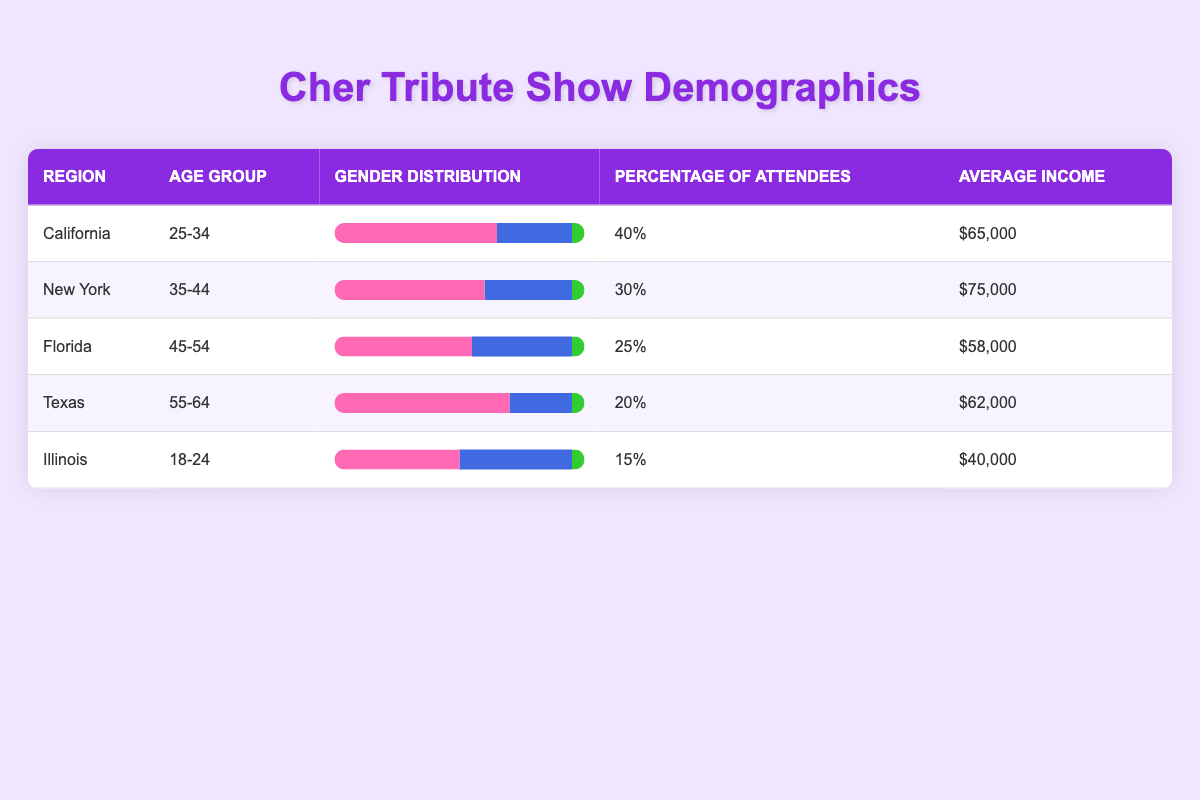What is the average income of attendees in Florida? The table shows that the average income for Florida is listed as $58,000. Therefore, this information can be directly retrieved from the table.
Answer: $58,000 Which region has the highest percentage of attendees? According to the table, California has the highest percentage of attendees at 40%, which is greater than the percentages listed for New York (30%), Florida (25%), Texas (20%), and Illinois (15%).
Answer: California Is the gender distribution for Texas primarily female? In Texas, the gender distribution indicates that 70% are female, which is a majority compared to males (25%) and others (5%). Thus, the statement is true.
Answer: Yes What is the combined percentage of attendees from California and New York? The percentage of attendees in California is 40%, and in New York, it is 30%. Adding these two percentages together (40 + 30) gives a total of 70%.
Answer: 70% Which age group has the lowest representation in terms of percentage of attendees? Upon examining the percentages of attendees, Illinois (18-24) has the lowest at 15%, compared to other regions: California (40%), New York (30%), Florida (25%), and Texas (20%).
Answer: Illinois How many total gender percentages sum to 100% for each region? Gender distribution percentages for California (65% female, 30% male, 5% other), New York (60% female, 35% male, 5% other), Florida (55% female, 40% male, 5% other), Texas (70% female, 25% male, 5% other), and Illinois (50% female, 45% male, 5% other) all add up to 100% for each region.
Answer: Yes Which region shows a male percentage higher than 30% in gender distribution? In analyzing the gender distribution, Florida has 40% male and New York has 35% male. Both are higher than 30%. Hence, the answer is based on those two regions meeting the criteria.
Answer: Florida, New York What is the average income of attendees across all regions? To find the average income, sum the incomes: ($65,000 + $75,000 + $58,000 + $62,000 + $40,000 = $300,000). There are 5 regions, so the average income is $300,000 / 5 = $60,000.
Answer: $60,000 